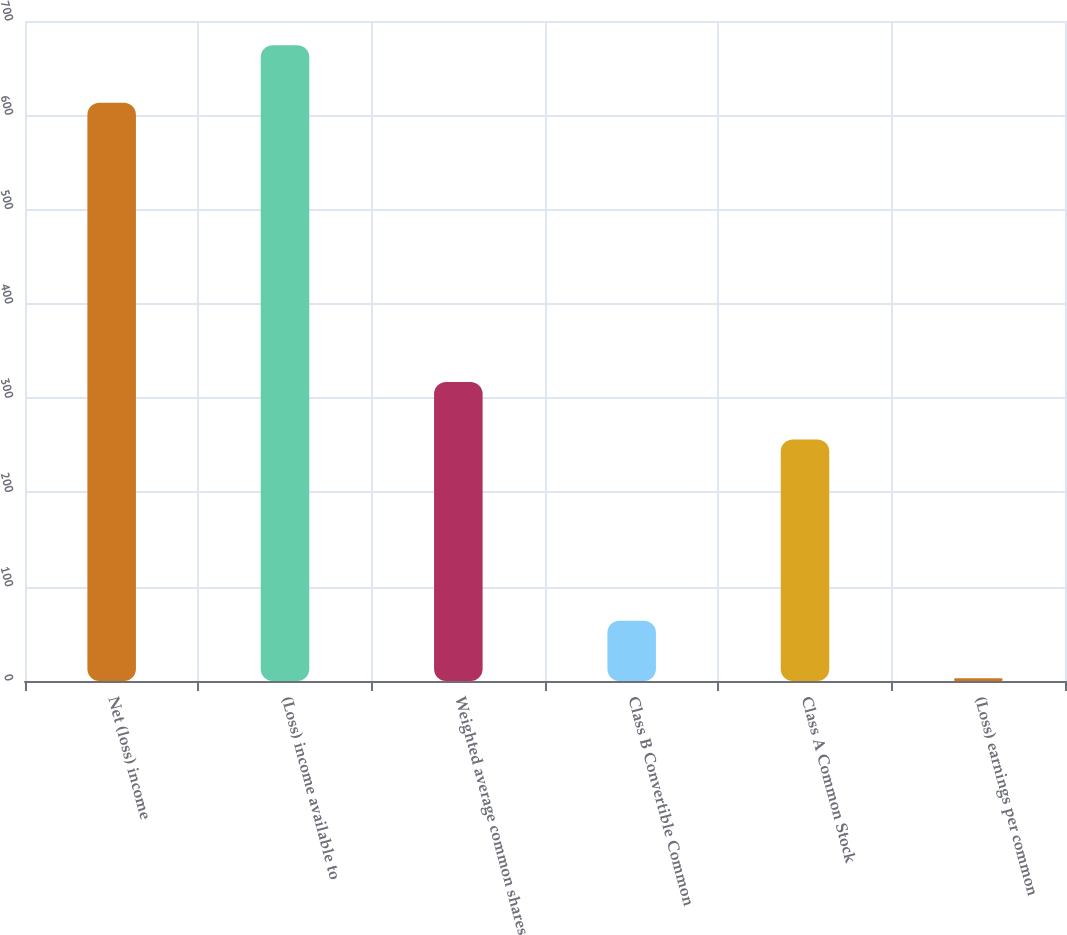<chart> <loc_0><loc_0><loc_500><loc_500><bar_chart><fcel>Net (loss) income<fcel>(Loss) income available to<fcel>Weighted average common shares<fcel>Class B Convertible Common<fcel>Class A Common Stock<fcel>(Loss) earnings per common<nl><fcel>613.3<fcel>674.35<fcel>317.23<fcel>63.88<fcel>256.18<fcel>2.83<nl></chart> 